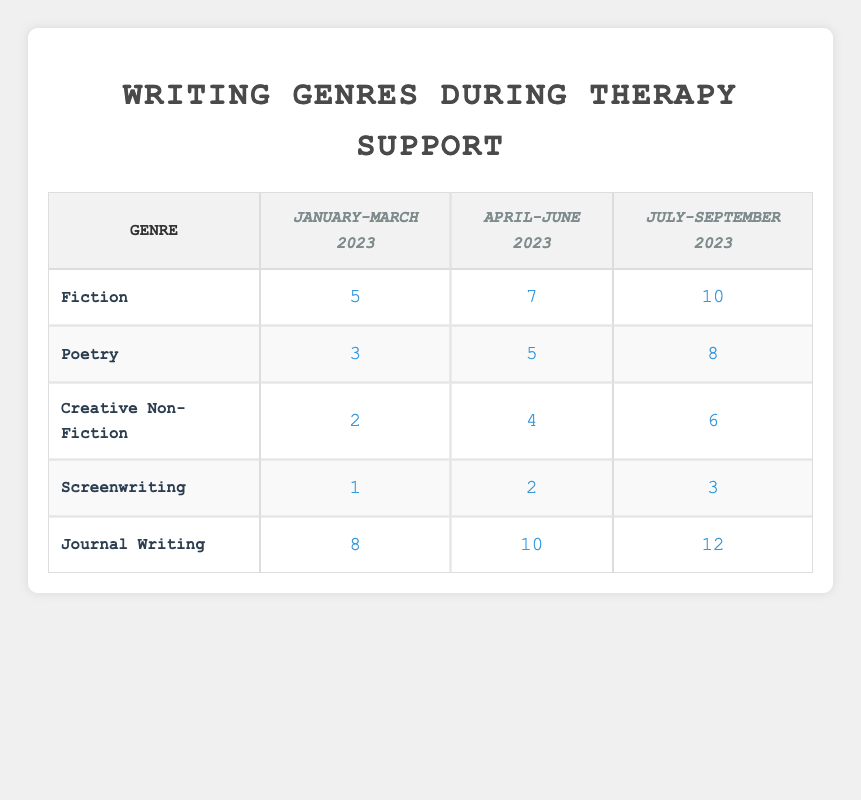What was the highest number of writing attempts in any genre during the July-September 2023 period? Looking at the table, we compare the attempts for all genres during the July-September 2023 period: Fiction (10), Poetry (8), Creative Non-Fiction (6), Screenwriting (3), and Journal Writing (12). The highest number of attempts is 12 in Journal Writing.
Answer: 12 How many attempts did you make for Creative Non-Fiction in April-June 2023? The table indicates that during April-June 2023, the attempts for Creative Non-Fiction were 4.
Answer: 4 Did the number of attempts for Screenwriting increase over the therapy periods? Yes, by observing the attempts for Screenwriting across the periods: January-March (1), April-June (2), July-September (3), we see an increase in the number of attempts in each subsequent period.
Answer: Yes What was the average number of attempts for Poetry across all therapy periods? To find the average, we calculate the attempts: January-March (3), April-June (5), July-September (8). Summing these gives us 3 + 5 + 8 = 16. With 3 data points, the average is 16 / 3 = 5.33.
Answer: 5.33 Which genre had the least number of attempts in the January-March 2023 period? In the January-March 2023 period, the attempts for each genre were: Fiction (5), Poetry (3), Creative Non-Fiction (2), Screenwriting (1), and Journal Writing (8). The least number of attempts is 1 in Screenwriting.
Answer: Screenwriting 